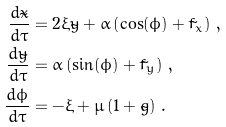Convert formula to latex. <formula><loc_0><loc_0><loc_500><loc_500>\frac { d \tilde { x } } { d \tau } & = 2 \xi \tilde { y } + \alpha \left ( \cos ( \phi ) + \tilde { f } _ { x } \right ) \, , \\ \frac { d \tilde { y } } { d \tau } & = \alpha \left ( \sin ( \phi ) + \tilde { f } _ { y } \right ) \, , \\ \frac { d \phi } { d \tau } & = - \xi + \mu \left ( 1 + \tilde { g } \right ) \, .</formula> 